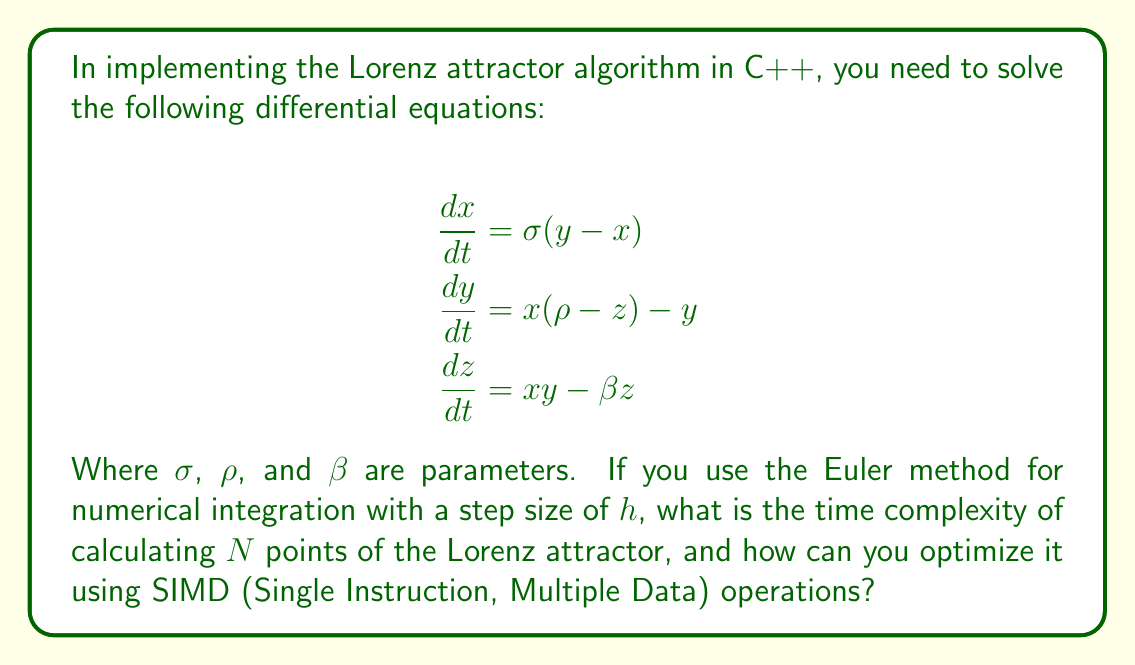Solve this math problem. Let's break this down step-by-step:

1) The Euler method for numerical integration is given by:
   $$x_{n+1} = x_n + h \cdot f(x_n, y_n, z_n)$$
   Where $f$ is the derivative function.

2) For each point, we need to calculate three new values (x, y, z). Each calculation involves a few arithmetic operations.

3) Without optimization, the time complexity for calculating N points is O(N), as we perform a constant number of operations for each point.

4) To optimize using SIMD, we can vectorize the calculations:
   - Group the x, y, z values into vectors
   - Perform operations on these vectors simultaneously

5) Modern CPUs support SIMD instructions that can operate on 4 or 8 float values at once (e.g., SSE or AVX instructions).

6) By using SIMD, we can potentially calculate 4 or 8 points simultaneously, reducing the number of iterations by a factor of 4 or 8.

7) This doesn't change the overall time complexity, which remains O(N), but it does reduce the constant factor significantly.

8) The optimized implementation would look something like this in pseudo-code:
   ```
   for i = 0 to N/4 (assuming SSE with 4-wide vectors):
       load x[i:i+3], y[i:i+3], z[i:i+3] into vector registers
       perform vectorized calculations
       store results back to x[i:i+3], y[i:i+3], z[i:i+3]
   ```

9) This SIMD optimization can potentially speed up the calculation by up to 4x (or more with wider SIMD instructions), although the actual speedup may vary depending on the specific hardware and implementation details.
Answer: O(N) time complexity; 4x speedup with SSE SIMD 